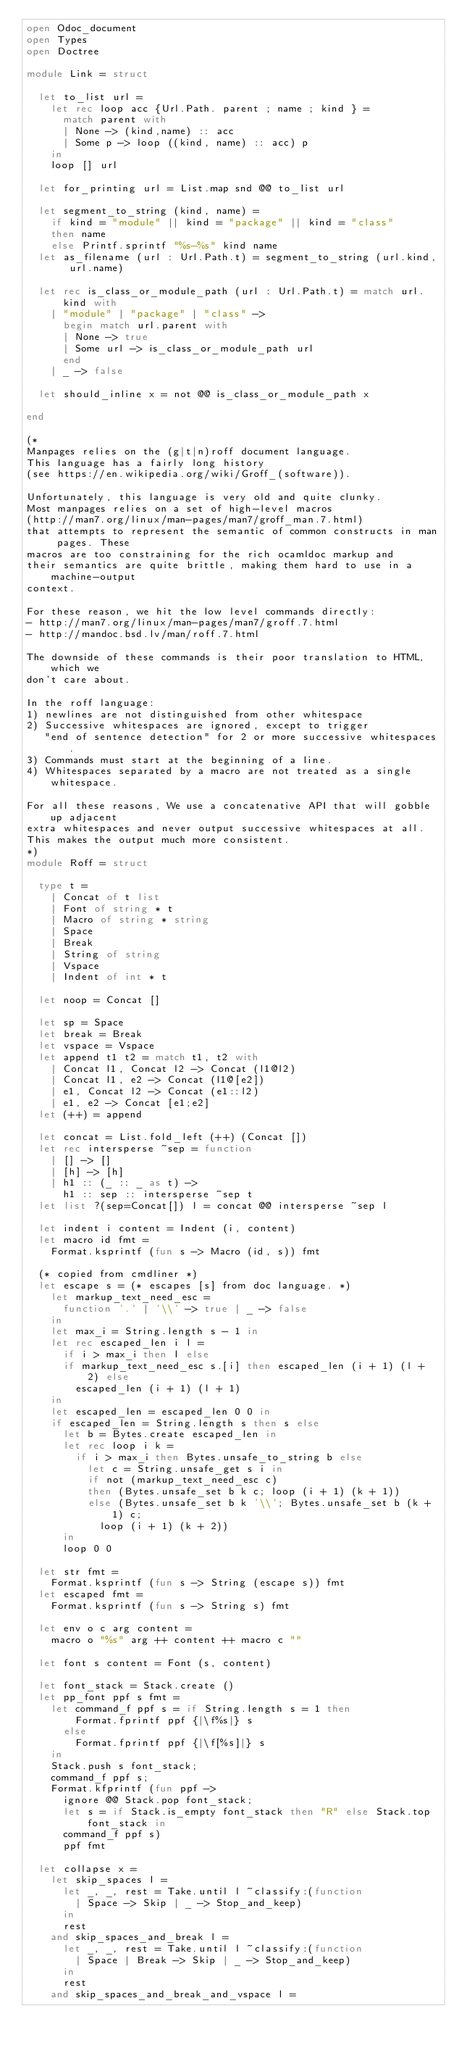<code> <loc_0><loc_0><loc_500><loc_500><_OCaml_>open Odoc_document
open Types
open Doctree

module Link = struct

  let to_list url =
    let rec loop acc {Url.Path. parent ; name ; kind } =
      match parent with
      | None -> (kind,name) :: acc
      | Some p -> loop ((kind, name) :: acc) p
    in
    loop [] url

  let for_printing url = List.map snd @@ to_list url

  let segment_to_string (kind, name) =
    if kind = "module" || kind = "package" || kind = "class"
    then name
    else Printf.sprintf "%s-%s" kind name
  let as_filename (url : Url.Path.t) = segment_to_string (url.kind, url.name)

  let rec is_class_or_module_path (url : Url.Path.t) = match url.kind with
    | "module" | "package" | "class" ->
      begin match url.parent with
      | None -> true
      | Some url -> is_class_or_module_path url
      end
    | _ -> false

  let should_inline x = not @@ is_class_or_module_path x

end

(*
Manpages relies on the (g|t|n)roff document language.
This language has a fairly long history
(see https://en.wikipedia.org/wiki/Groff_(software)).

Unfortunately, this language is very old and quite clunky.
Most manpages relies on a set of high-level macros
(http://man7.org/linux/man-pages/man7/groff_man.7.html)
that attempts to represent the semantic of common constructs in man pages. These
macros are too constraining for the rich ocamldoc markup and
their semantics are quite brittle, making them hard to use in a machine-output
context.

For these reason, we hit the low level commands directly:
- http://man7.org/linux/man-pages/man7/groff.7.html
- http://mandoc.bsd.lv/man/roff.7.html

The downside of these commands is their poor translation to HTML, which we
don't care about.

In the roff language:
1) newlines are not distinguished from other whitespace
2) Successive whitespaces are ignored, except to trigger
   "end of sentence detection" for 2 or more successive whitespaces.
3) Commands must start at the beginning of a line.
4) Whitespaces separated by a macro are not treated as a single whitespace.

For all these reasons, We use a concatenative API that will gobble up adjacent
extra whitespaces and never output successive whitespaces at all.
This makes the output much more consistent.
*)
module Roff = struct

  type t =
    | Concat of t list
    | Font of string * t
    | Macro of string * string
    | Space
    | Break
    | String of string
    | Vspace
    | Indent of int * t

  let noop = Concat []

  let sp = Space
  let break = Break
  let vspace = Vspace
  let append t1 t2 = match t1, t2 with
    | Concat l1, Concat l2 -> Concat (l1@l2)
    | Concat l1, e2 -> Concat (l1@[e2])
    | e1, Concat l2 -> Concat (e1::l2)
    | e1, e2 -> Concat [e1;e2]
  let (++) = append

  let concat = List.fold_left (++) (Concat [])
  let rec intersperse ~sep = function
    | [] -> []
    | [h] -> [h]
    | h1 :: (_ :: _ as t) ->
      h1 :: sep :: intersperse ~sep t
  let list ?(sep=Concat[]) l = concat @@ intersperse ~sep l

  let indent i content = Indent (i, content)
  let macro id fmt =
    Format.ksprintf (fun s -> Macro (id, s)) fmt

  (* copied from cmdliner *)
  let escape s = (* escapes [s] from doc language. *)
    let markup_text_need_esc =
      function '.' | '\\' -> true | _ -> false
    in
    let max_i = String.length s - 1 in
    let rec escaped_len i l =
      if i > max_i then l else
      if markup_text_need_esc s.[i] then escaped_len (i + 1) (l + 2) else
        escaped_len (i + 1) (l + 1)
    in
    let escaped_len = escaped_len 0 0 in
    if escaped_len = String.length s then s else
      let b = Bytes.create escaped_len in
      let rec loop i k =
        if i > max_i then Bytes.unsafe_to_string b else
          let c = String.unsafe_get s i in
          if not (markup_text_need_esc c)
          then (Bytes.unsafe_set b k c; loop (i + 1) (k + 1))
          else (Bytes.unsafe_set b k '\\'; Bytes.unsafe_set b (k + 1) c;
            loop (i + 1) (k + 2))
      in
      loop 0 0

  let str fmt =
    Format.ksprintf (fun s -> String (escape s)) fmt
  let escaped fmt =
    Format.ksprintf (fun s -> String s) fmt

  let env o c arg content =
    macro o "%s" arg ++ content ++ macro c ""

  let font s content = Font (s, content)

  let font_stack = Stack.create ()
  let pp_font ppf s fmt =
    let command_f ppf s = if String.length s = 1 then
        Format.fprintf ppf {|\f%s|} s
      else
        Format.fprintf ppf {|\f[%s]|} s
    in
    Stack.push s font_stack;
    command_f ppf s;
    Format.kfprintf (fun ppf ->
      ignore @@ Stack.pop font_stack;
      let s = if Stack.is_empty font_stack then "R" else Stack.top font_stack in
      command_f ppf s)
      ppf fmt

  let collapse x =
    let skip_spaces l =
      let _, _, rest = Take.until l ~classify:(function
        | Space -> Skip | _ -> Stop_and_keep)
      in
      rest
    and skip_spaces_and_break l =
      let _, _, rest = Take.until l ~classify:(function
        | Space | Break -> Skip | _ -> Stop_and_keep)
      in
      rest
    and skip_spaces_and_break_and_vspace l =</code> 